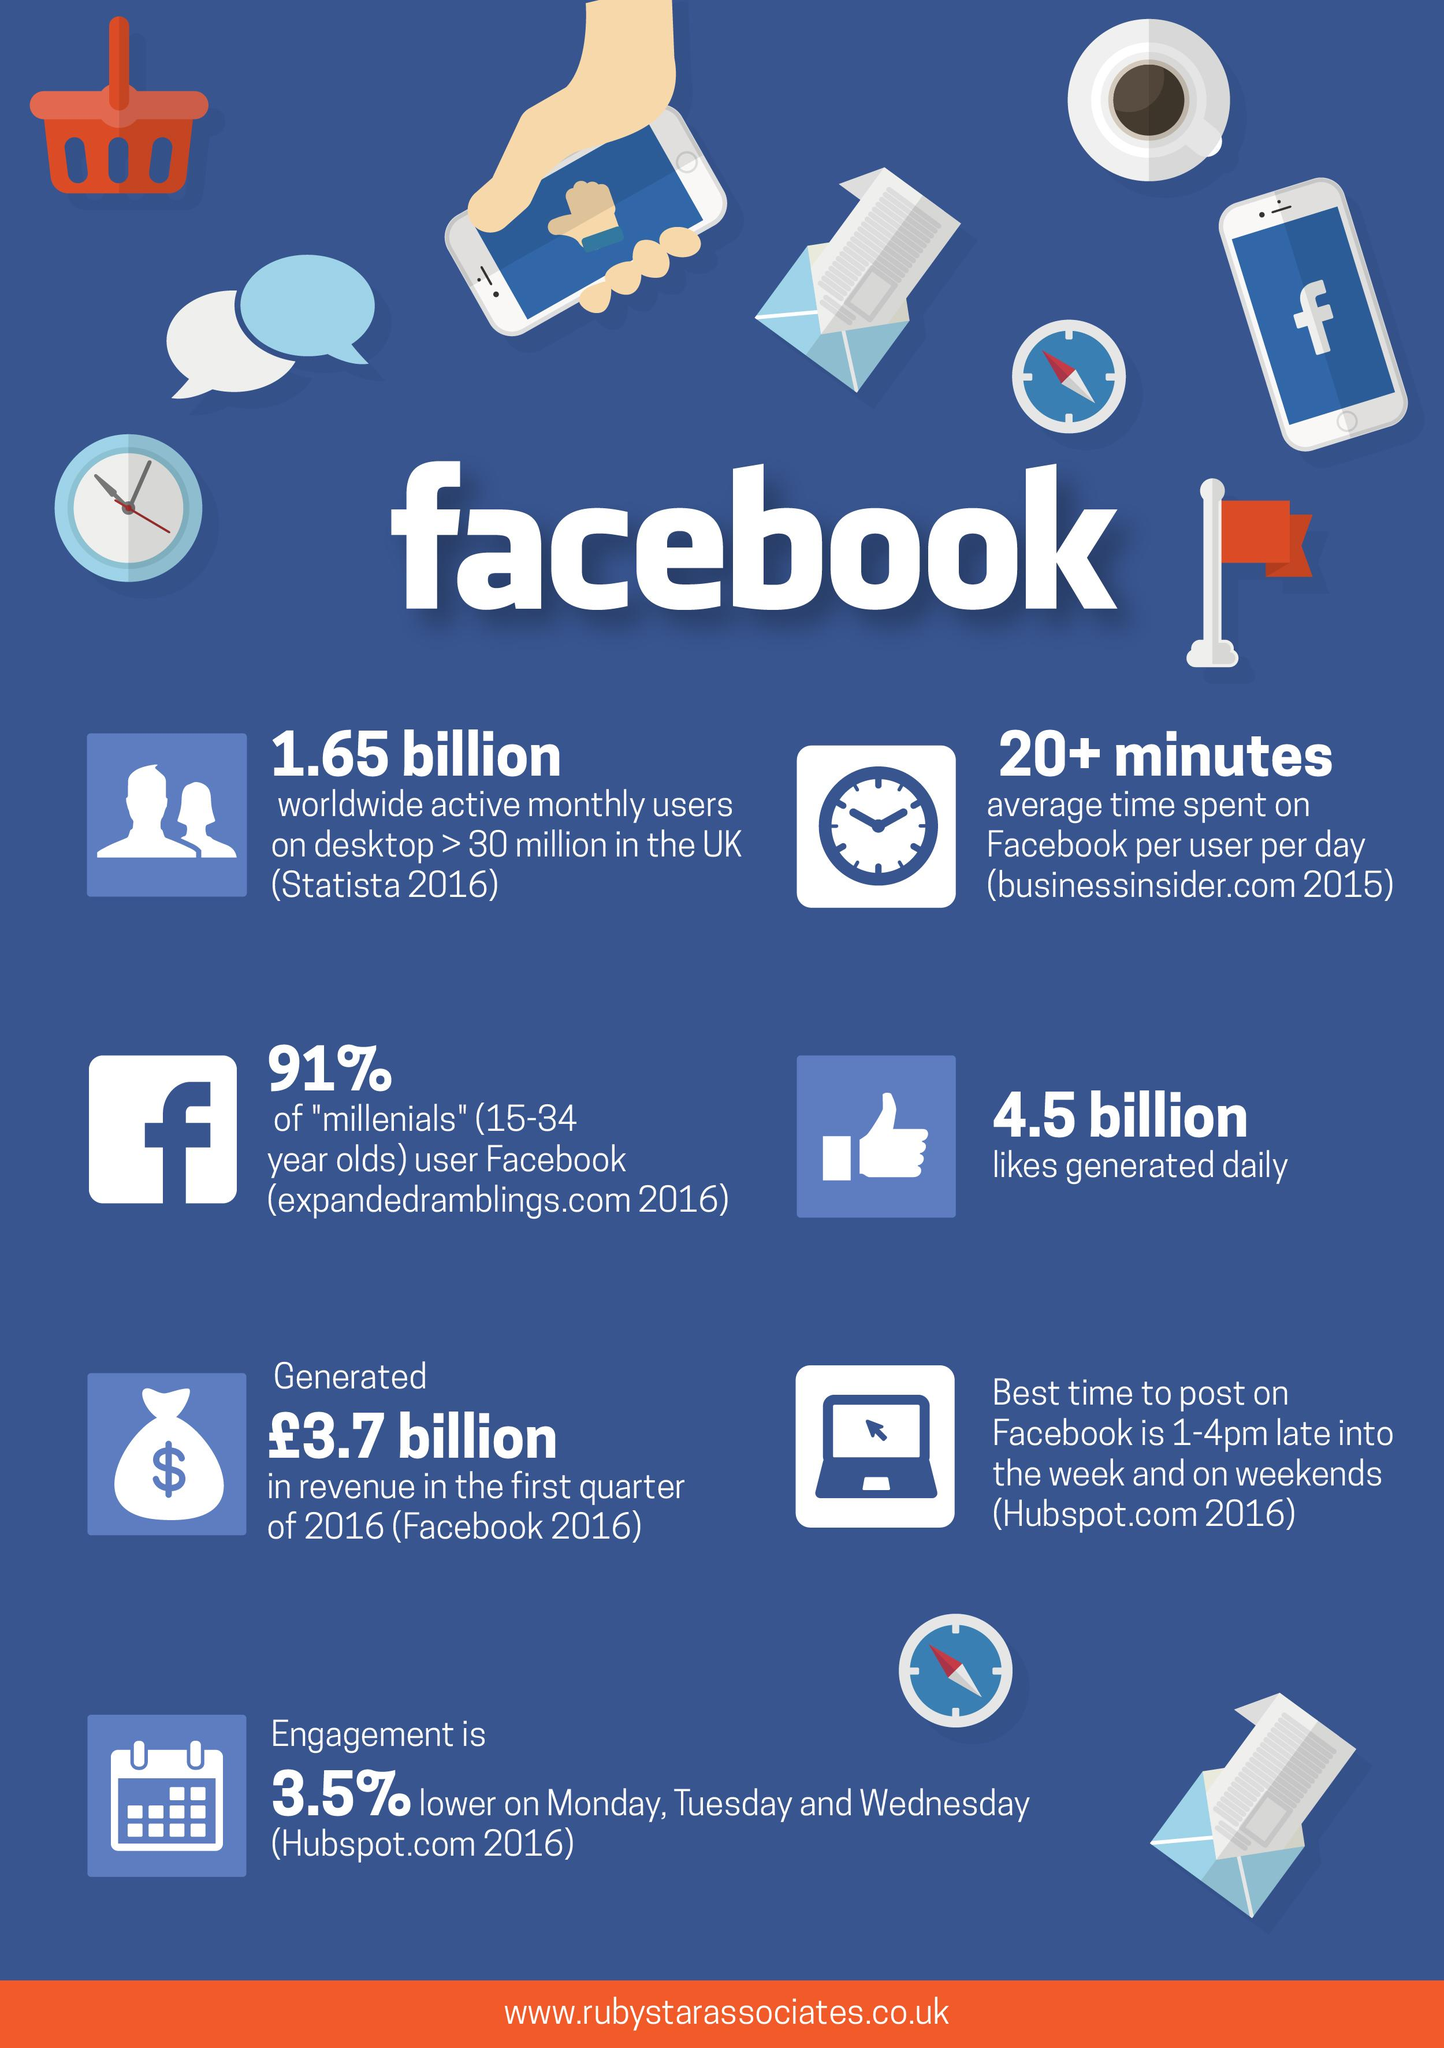Identify some key points in this picture. During the week, the engagement is likely to be low on Monday, Tuesday, and Wednesday. 